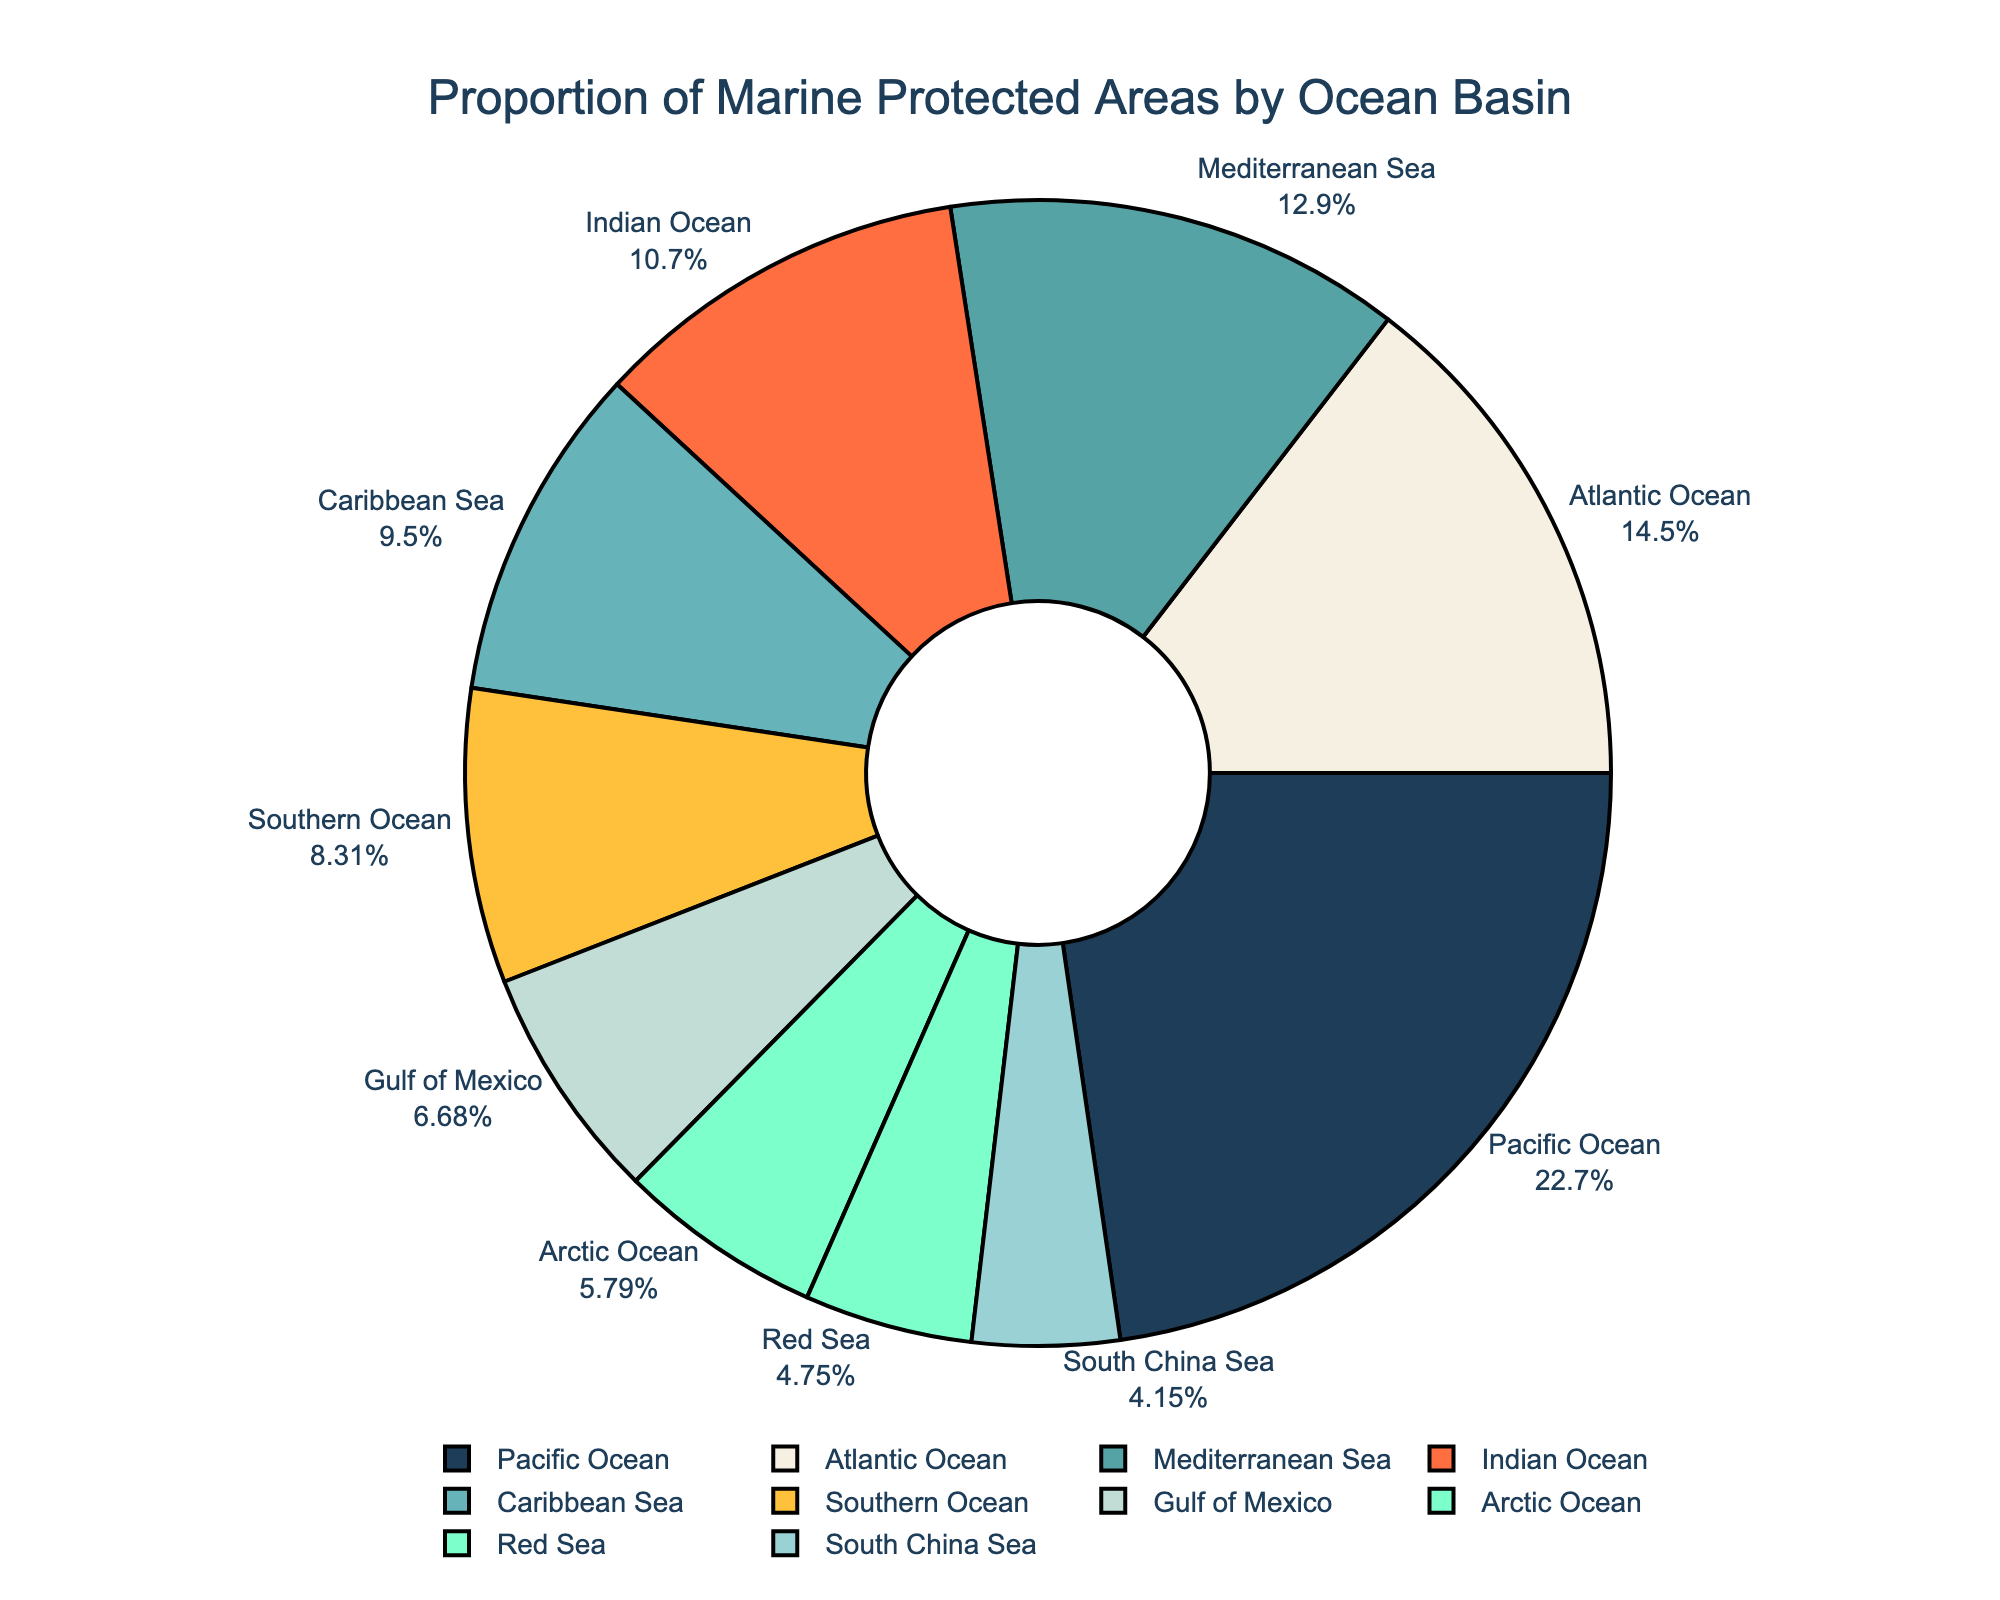What's the ocean basin with the highest proportion of marine protected areas? The Pacific Ocean slice is the largest one in the pie chart and its label indicates the highest proportion of marine protected areas.
Answer: Pacific Ocean Which ocean basin has a slightly lower proportion of protected areas than the Atlantic Ocean? The Mediterranean Sea has a proportion of protected areas that is slightly lower than the Atlantic Ocean as indicated by its adjacent smaller slice in the chart.
Answer: Mediterranean Sea Combine the proportions of protected areas for the Atlantic Ocean, Mediterranean Sea, and Caribbean Sea. What's the total percentage? The proportions are 9.8% (Atlantic Ocean) + 8.7% (Mediterranean Sea) + 6.4% (Caribbean Sea). Adding them up gives 24.9%.
Answer: 24.9% Compare the proportions of marine protected areas between the Indian Ocean and the Arctic Ocean. Which one is greater and by how much? Reviewing the chart, the Indian Ocean has 7.2% and the Arctic Ocean has 3.9%. The difference is 7.2% - 3.9% = 3.3%.
Answer: Indian Ocean, by 3.3% What's the proportion of protected areas in the Southern Ocean relative to the Gulf of Mexico? The Southern Ocean has 5.6% while the Gulf of Mexico has 4.5%. Thus, the Southern Ocean's proportion is greater than the Gulf of Mexico's by 5.6% - 4.5% = 1.1%.
Answer: Greater by 1.1% Which ocean basin has a higher proportion of marine protected areas: the Red Sea or the South China Sea? The Red Sea shows a proportion of 3.2% and the South China Sea 2.8%, hence the Red Sea has a slightly higher proportion.
Answer: Red Sea Sum up the proportions of marine protected areas for the Arctic Ocean, Red Sea, and South China Sea. What's the total percentage? Adding the proportions results in 3.9% (Arctic Ocean) + 3.2% (Red Sea) + 2.8% (South China Sea) = 9.9%.
Answer: 9.9% How does the proportion of marine protected areas in the Southern Ocean compare visually to that in the Caribbean Sea? Visually, the Southern Ocean's protected area slice is slightly smaller than the Caribbean Sea's slice in the pie chart.
Answer: Smaller What's the average proportion of marine protected areas across the top three ocean basins by proportion? The top three are Pacific Ocean (15.3%), Atlantic Ocean (9.8%), and Mediterranean Sea (8.7%). The average is (15.3 + 9.8 + 8.7) / 3 = 11.27%.
Answer: 11.27% Which ocean basin's proportion of marine protected areas is less than a third of the Pacific Ocean's? The Pacific Ocean's proportion is 15.3%. One third of this is 15.3 / 3 = 5.1%. The Arctic Ocean (3.9%), South China Sea (2.8%), and Red Sea (3.2%) are all below this threshold.
Answer: Arctic Ocean, South China Sea, Red Sea 